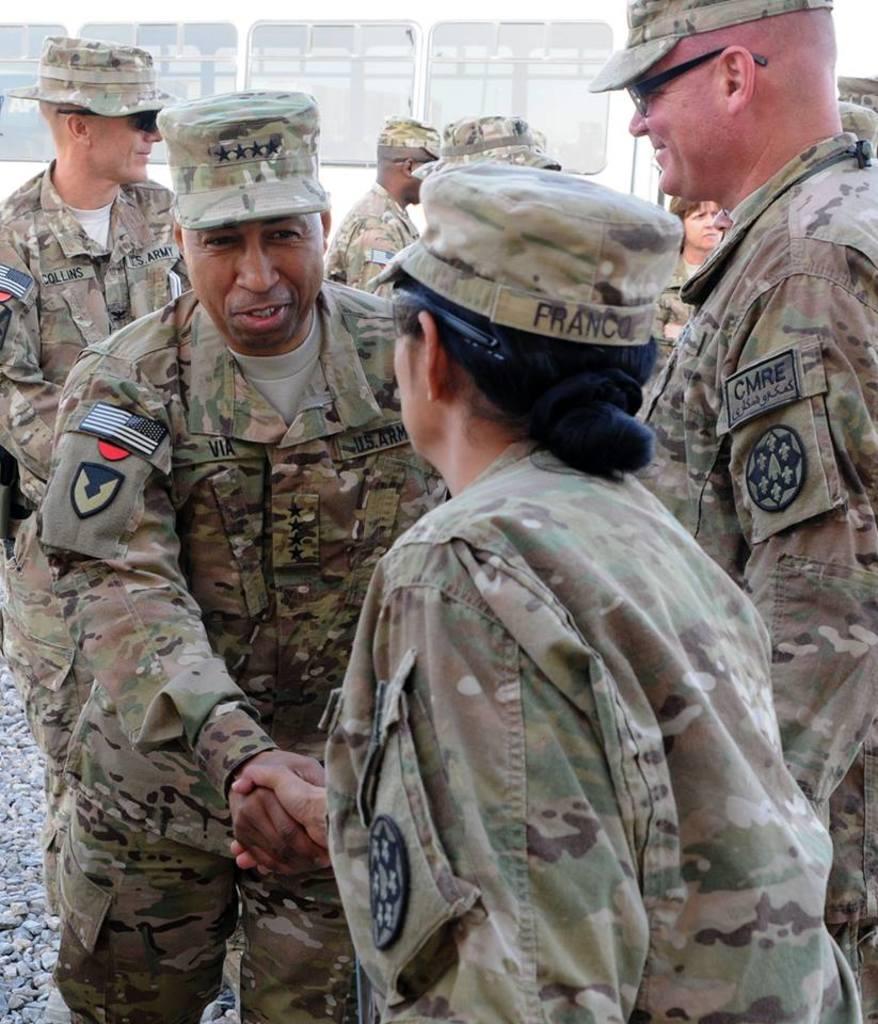Could you give a brief overview of what you see in this image? In this image, there are a few people. We can see the ground with some stones. In the background, we can see the metal wall with some glass windows. 